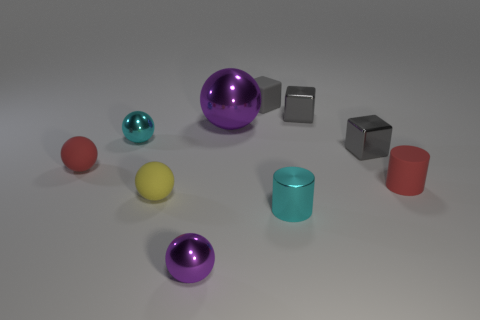How many matte things are either red things or big objects?
Your response must be concise. 2. Are any cyan balls visible?
Your answer should be very brief. Yes. Is the small yellow object the same shape as the tiny gray rubber thing?
Provide a short and direct response. No. There is a tiny matte ball to the right of the tiny matte thing that is to the left of the small yellow ball; what number of big purple things are in front of it?
Give a very brief answer. 0. What material is the small block that is behind the large purple object and in front of the rubber block?
Offer a terse response. Metal. There is a metallic ball that is to the right of the cyan sphere and behind the shiny cylinder; what color is it?
Make the answer very short. Purple. Is there any other thing of the same color as the large metallic sphere?
Keep it short and to the point. Yes. What is the shape of the small red thing to the right of the purple shiny ball left of the purple metal ball that is behind the tiny red matte cylinder?
Provide a succinct answer. Cylinder. There is another big metallic thing that is the same shape as the yellow thing; what is its color?
Provide a succinct answer. Purple. There is a small metallic ball that is to the left of the purple metal sphere that is in front of the red matte cylinder; what color is it?
Keep it short and to the point. Cyan. 